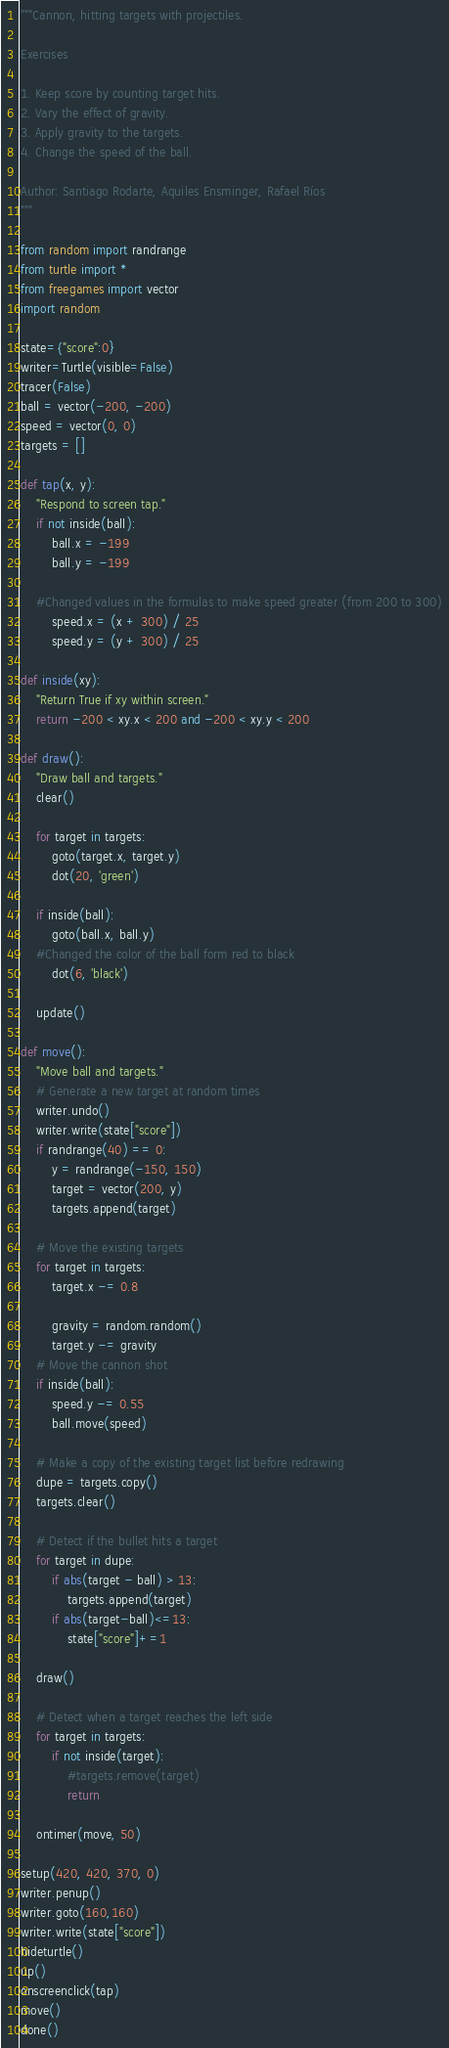Convert code to text. <code><loc_0><loc_0><loc_500><loc_500><_Python_>"""Cannon, hitting targets with projectiles.

Exercises

1. Keep score by counting target hits.
2. Vary the effect of gravity.
3. Apply gravity to the targets.
4. Change the speed of the ball.

Author: Santiago Rodarte, Aquiles Ensminger, Rafael Ríos
"""

from random import randrange
from turtle import *
from freegames import vector
import random

state={"score":0}
writer=Turtle(visible=False)
tracer(False)
ball = vector(-200, -200)
speed = vector(0, 0)
targets = []

def tap(x, y):
    "Respond to screen tap."
    if not inside(ball):
        ball.x = -199
        ball.y = -199

	#Changed values in the formulas to make speed greater (from 200 to 300)
        speed.x = (x + 300) / 25 
        speed.y = (y + 300) / 25

def inside(xy):
    "Return True if xy within screen."
    return -200 < xy.x < 200 and -200 < xy.y < 200

def draw():
    "Draw ball and targets."
    clear()

    for target in targets:
        goto(target.x, target.y)
        dot(20, 'green')

    if inside(ball):
        goto(ball.x, ball.y)
	#Changed the color of the ball form red to black
        dot(6, 'black')

    update()

def move():
    "Move ball and targets."
    # Generate a new target at random times
    writer.undo()
    writer.write(state["score"]) 
    if randrange(40) == 0:
        y = randrange(-150, 150)
        target = vector(200, y)
        targets.append(target)

    # Move the existing targets
    for target in targets:
        target.x -= 0.8

        gravity = random.random()
        target.y -= gravity
    # Move the cannon shot
    if inside(ball):
        speed.y -= 0.55
        ball.move(speed)

    # Make a copy of the existing target list before redrawing
    dupe = targets.copy()
    targets.clear()

    # Detect if the bullet hits a target
    for target in dupe:
        if abs(target - ball) > 13:
            targets.append(target)
        if abs(target-ball)<=13:    
            state["score"]+=1
    
    draw()

    # Detect when a target reaches the left side
    for target in targets:
        if not inside(target):
            #targets.remove(target)
            return

    ontimer(move, 50)

setup(420, 420, 370, 0)
writer.penup()
writer.goto(160,160)
writer.write(state["score"])
hideturtle()
up()
onscreenclick(tap)
move()
done()
</code> 